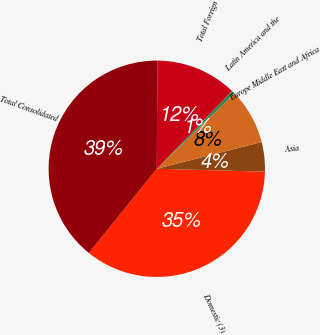Convert chart. <chart><loc_0><loc_0><loc_500><loc_500><pie_chart><fcel>Domestic (3)<fcel>Asia<fcel>Europe Middle East and Africa<fcel>Latin America and the<fcel>Total Foreign<fcel>Total Consolidated<nl><fcel>35.38%<fcel>4.4%<fcel>8.27%<fcel>0.52%<fcel>12.15%<fcel>39.28%<nl></chart> 